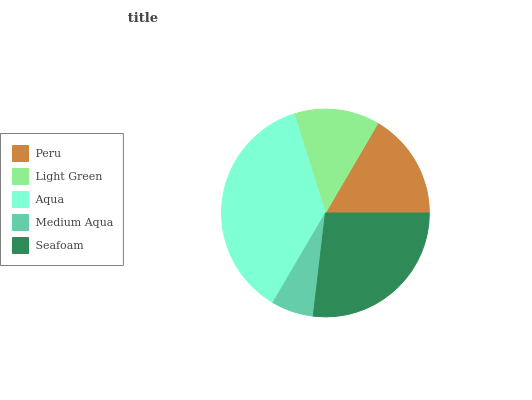Is Medium Aqua the minimum?
Answer yes or no. Yes. Is Aqua the maximum?
Answer yes or no. Yes. Is Light Green the minimum?
Answer yes or no. No. Is Light Green the maximum?
Answer yes or no. No. Is Peru greater than Light Green?
Answer yes or no. Yes. Is Light Green less than Peru?
Answer yes or no. Yes. Is Light Green greater than Peru?
Answer yes or no. No. Is Peru less than Light Green?
Answer yes or no. No. Is Peru the high median?
Answer yes or no. Yes. Is Peru the low median?
Answer yes or no. Yes. Is Light Green the high median?
Answer yes or no. No. Is Medium Aqua the low median?
Answer yes or no. No. 